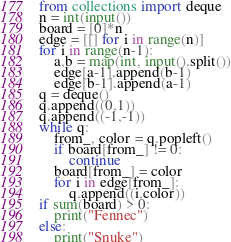<code> <loc_0><loc_0><loc_500><loc_500><_Python_>from collections import deque
n = int(input())
board = [0]*n
edge = [[] for i in range(n)]
for i in range(n-1):
    a,b = map(int, input().split())
    edge[a-1].append(b-1)
    edge[b-1].append(a-1)
q = deque()
q.append((0,1))
q.append((-1,-1))
while q:
    from_, color = q.popleft()
    if board[from_] != 0:
        continue
    board[from_] = color
    for i in edge[from_]:
        q.append((i,color))
if sum(board) > 0:
    print("Fennec")
else:
    print("Snuke")</code> 